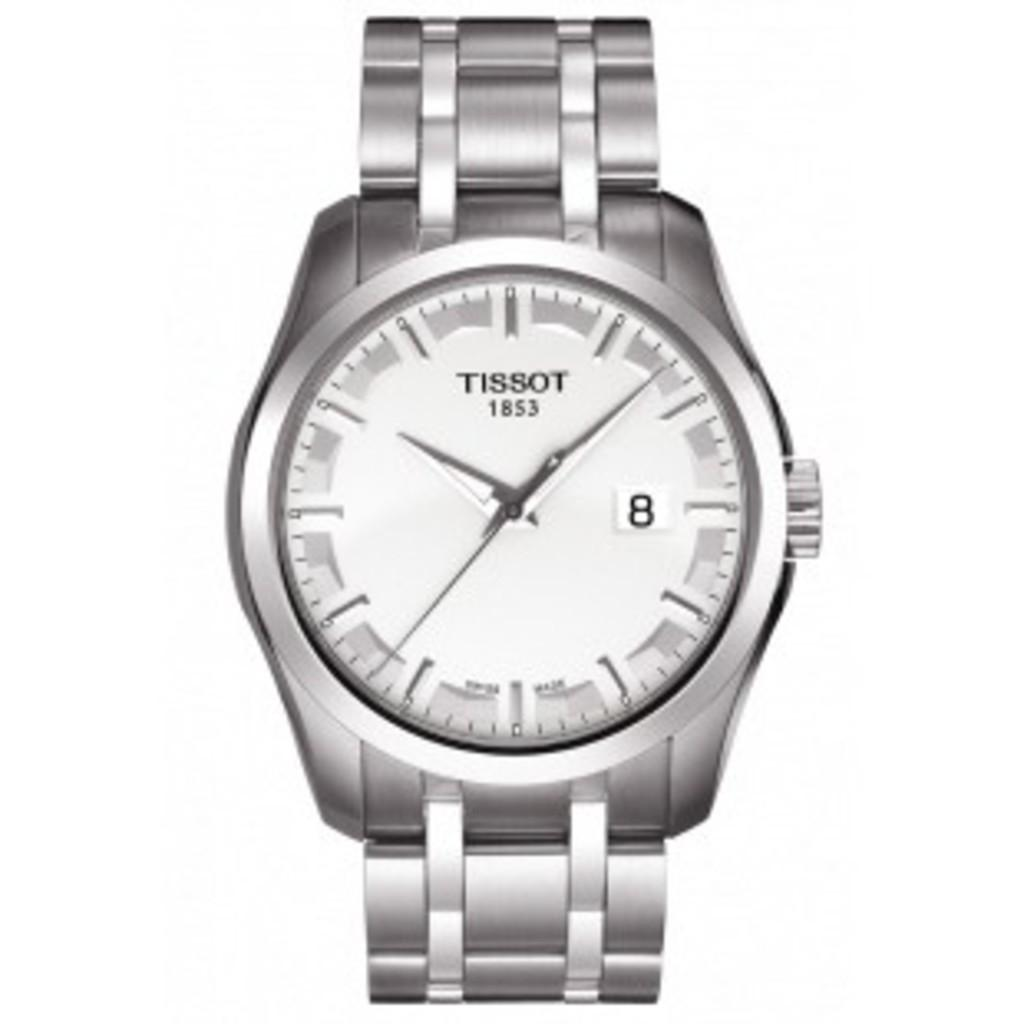<image>
Render a clear and concise summary of the photo. A silver watch by Tissot shows the time to be just after 10 o'clock. 